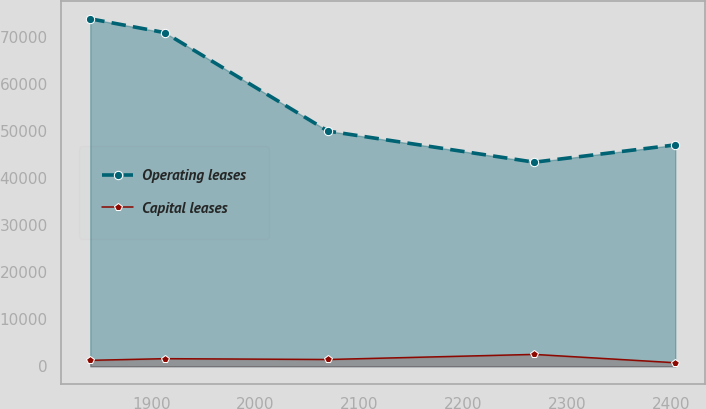Convert chart to OTSL. <chart><loc_0><loc_0><loc_500><loc_500><line_chart><ecel><fcel>Operating leases<fcel>Capital leases<nl><fcel>1841.07<fcel>73893.5<fcel>1261.85<nl><fcel>1912.69<fcel>70957.6<fcel>1617.15<nl><fcel>2069.71<fcel>50019.7<fcel>1439.5<nl><fcel>2268.31<fcel>43402<fcel>2526.67<nl><fcel>2403.93<fcel>47083.8<fcel>750.2<nl></chart> 